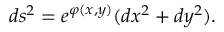Convert formula to latex. <formula><loc_0><loc_0><loc_500><loc_500>d s ^ { 2 } = e ^ { \varphi ( x , y ) } ( d x ^ { 2 } + d y ^ { 2 } ) .</formula> 